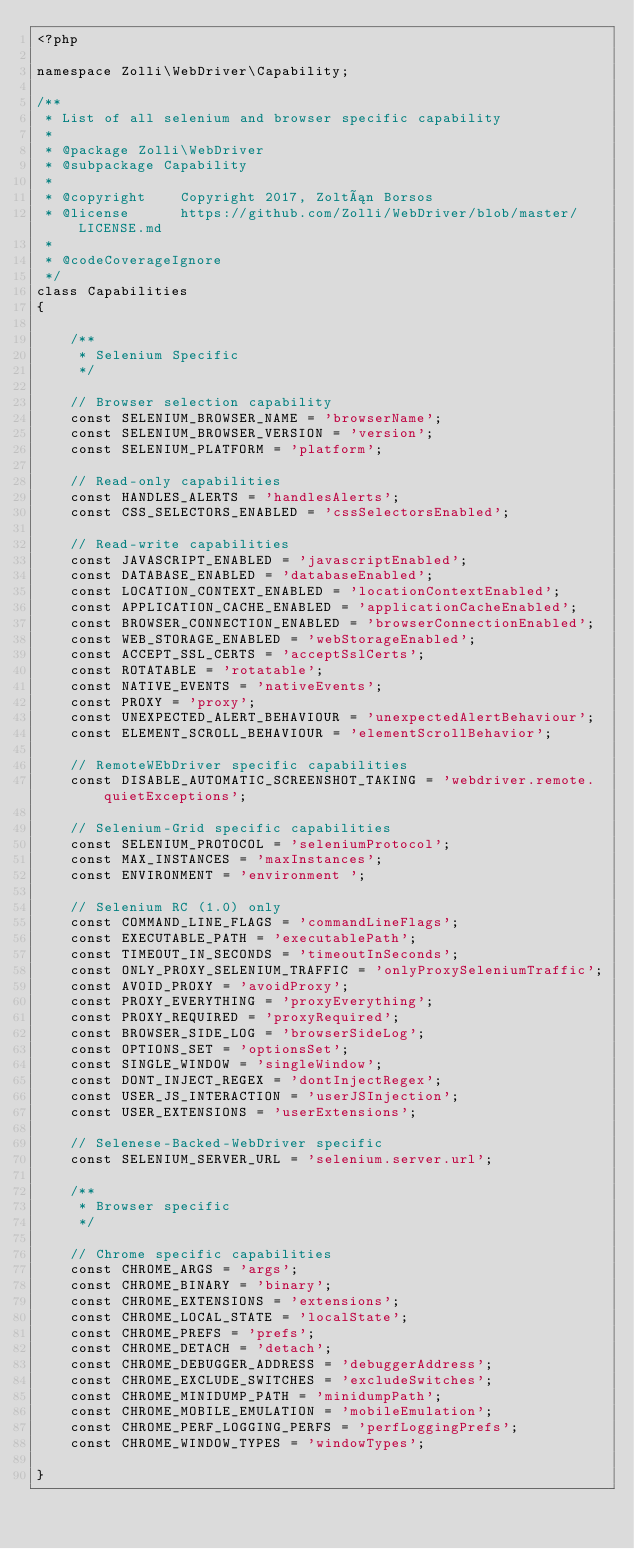Convert code to text. <code><loc_0><loc_0><loc_500><loc_500><_PHP_><?php

namespace Zolli\WebDriver\Capability;

/**
 * List of all selenium and browser specific capability
 *
 * @package Zolli\WebDriver
 * @subpackage Capability
 *
 * @copyright    Copyright 2017, Zoltán Borsos
 * @license      https://github.com/Zolli/WebDriver/blob/master/LICENSE.md
 *
 * @codeCoverageIgnore
 */
class Capabilities
{

    /**
     * Selenium Specific
     */

    // Browser selection capability
    const SELENIUM_BROWSER_NAME = 'browserName';
    const SELENIUM_BROWSER_VERSION = 'version';
    const SELENIUM_PLATFORM = 'platform';

    // Read-only capabilities
    const HANDLES_ALERTS = 'handlesAlerts';
    const CSS_SELECTORS_ENABLED = 'cssSelectorsEnabled';

    // Read-write capabilities
    const JAVASCRIPT_ENABLED = 'javascriptEnabled';
    const DATABASE_ENABLED = 'databaseEnabled';
    const LOCATION_CONTEXT_ENABLED = 'locationContextEnabled';
    const APPLICATION_CACHE_ENABLED = 'applicationCacheEnabled';
    const BROWSER_CONNECTION_ENABLED = 'browserConnectionEnabled';
    const WEB_STORAGE_ENABLED = 'webStorageEnabled';
    const ACCEPT_SSL_CERTS = 'acceptSslCerts';
    const ROTATABLE = 'rotatable';
    const NATIVE_EVENTS = 'nativeEvents';
    const PROXY = 'proxy';
    const UNEXPECTED_ALERT_BEHAVIOUR = 'unexpectedAlertBehaviour';
    const ELEMENT_SCROLL_BEHAVIOUR = 'elementScrollBehavior';

    // RemoteWEbDriver specific capabilities
    const DISABLE_AUTOMATIC_SCREENSHOT_TAKING = 'webdriver.remote.quietExceptions';

    // Selenium-Grid specific capabilities
    const SELENIUM_PROTOCOL = 'seleniumProtocol';
    const MAX_INSTANCES = 'maxInstances';
    const ENVIRONMENT = 'environment ';

    // Selenium RC (1.0) only
    const COMMAND_LINE_FLAGS = 'commandLineFlags';
    const EXECUTABLE_PATH = 'executablePath';
    const TIMEOUT_IN_SECONDS = 'timeoutInSeconds';
    const ONLY_PROXY_SELENIUM_TRAFFIC = 'onlyProxySeleniumTraffic';
    const AVOID_PROXY = 'avoidProxy';
    const PROXY_EVERYTHING = 'proxyEverything';
    const PROXY_REQUIRED = 'proxyRequired';
    const BROWSER_SIDE_LOG = 'browserSideLog';
    const OPTIONS_SET = 'optionsSet';
    const SINGLE_WINDOW = 'singleWindow';
    const DONT_INJECT_REGEX = 'dontInjectRegex';
    const USER_JS_INTERACTION = 'userJSInjection';
    const USER_EXTENSIONS = 'userExtensions';

    // Selenese-Backed-WebDriver specific
    const SELENIUM_SERVER_URL = 'selenium.server.url';

    /**
     * Browser specific
     */

    // Chrome specific capabilities
    const CHROME_ARGS = 'args';
    const CHROME_BINARY = 'binary';
    const CHROME_EXTENSIONS = 'extensions';
    const CHROME_LOCAL_STATE = 'localState';
    const CHROME_PREFS = 'prefs';
    const CHROME_DETACH = 'detach';
    const CHROME_DEBUGGER_ADDRESS = 'debuggerAddress';
    const CHROME_EXCLUDE_SWITCHES = 'excludeSwitches';
    const CHROME_MINIDUMP_PATH = 'minidumpPath';
    const CHROME_MOBILE_EMULATION = 'mobileEmulation';
    const CHROME_PERF_LOGGING_PERFS = 'perfLoggingPrefs';
    const CHROME_WINDOW_TYPES = 'windowTypes';

}</code> 